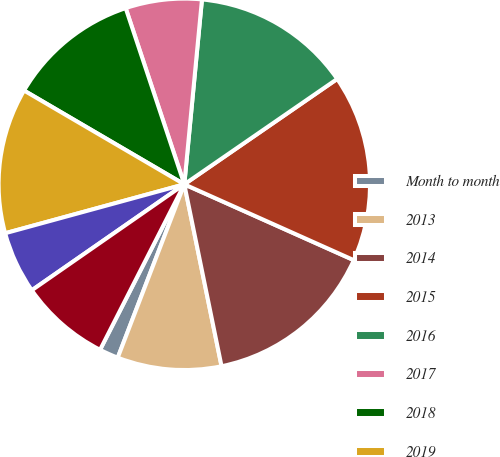<chart> <loc_0><loc_0><loc_500><loc_500><pie_chart><fcel>Month to month<fcel>2013<fcel>2014<fcel>2015<fcel>2016<fcel>2017<fcel>2018<fcel>2019<fcel>2020<fcel>2021<nl><fcel>1.66%<fcel>9.05%<fcel>15.09%<fcel>16.3%<fcel>13.88%<fcel>6.63%<fcel>11.46%<fcel>12.67%<fcel>5.42%<fcel>7.84%<nl></chart> 